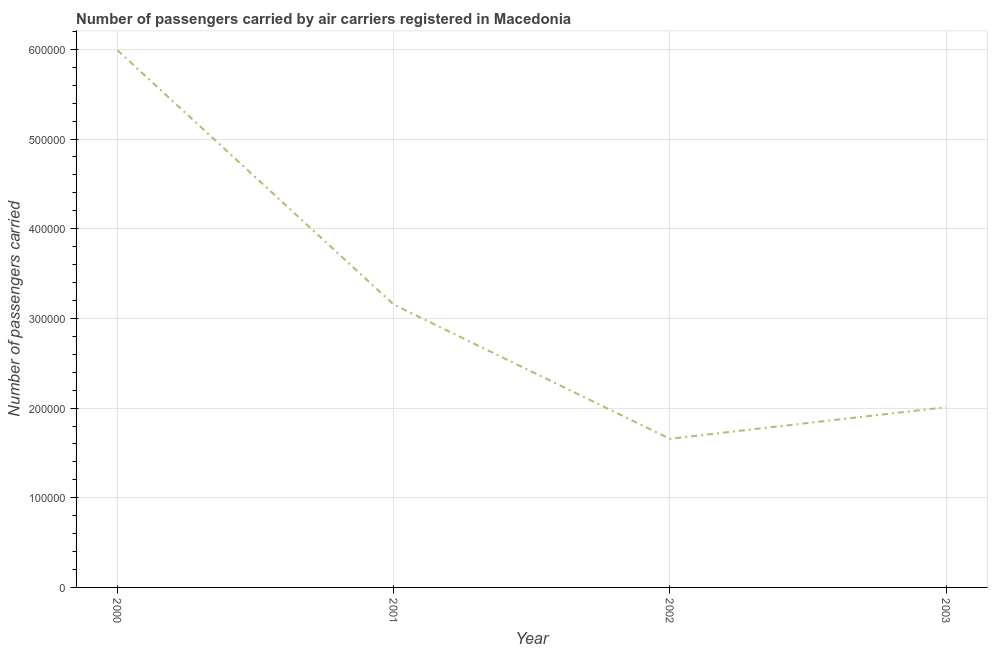What is the number of passengers carried in 2001?
Ensure brevity in your answer.  3.15e+05. Across all years, what is the maximum number of passengers carried?
Your response must be concise. 5.99e+05. Across all years, what is the minimum number of passengers carried?
Offer a terse response. 1.66e+05. In which year was the number of passengers carried minimum?
Your answer should be very brief. 2002. What is the sum of the number of passengers carried?
Make the answer very short. 1.28e+06. What is the difference between the number of passengers carried in 2000 and 2001?
Your answer should be very brief. 2.84e+05. What is the average number of passengers carried per year?
Offer a terse response. 3.20e+05. What is the median number of passengers carried?
Offer a very short reply. 2.58e+05. In how many years, is the number of passengers carried greater than 520000 ?
Provide a succinct answer. 1. Do a majority of the years between 2001 and 2003 (inclusive) have number of passengers carried greater than 300000 ?
Ensure brevity in your answer.  No. What is the ratio of the number of passengers carried in 2002 to that in 2003?
Ensure brevity in your answer.  0.82. What is the difference between the highest and the second highest number of passengers carried?
Your response must be concise. 2.84e+05. Is the sum of the number of passengers carried in 2002 and 2003 greater than the maximum number of passengers carried across all years?
Give a very brief answer. No. What is the difference between the highest and the lowest number of passengers carried?
Your answer should be very brief. 4.33e+05. How many years are there in the graph?
Your answer should be very brief. 4. What is the difference between two consecutive major ticks on the Y-axis?
Keep it short and to the point. 1.00e+05. Are the values on the major ticks of Y-axis written in scientific E-notation?
Keep it short and to the point. No. What is the title of the graph?
Keep it short and to the point. Number of passengers carried by air carriers registered in Macedonia. What is the label or title of the X-axis?
Provide a succinct answer. Year. What is the label or title of the Y-axis?
Provide a succinct answer. Number of passengers carried. What is the Number of passengers carried in 2000?
Keep it short and to the point. 5.99e+05. What is the Number of passengers carried in 2001?
Offer a very short reply. 3.15e+05. What is the Number of passengers carried in 2002?
Offer a terse response. 1.66e+05. What is the Number of passengers carried of 2003?
Your response must be concise. 2.01e+05. What is the difference between the Number of passengers carried in 2000 and 2001?
Give a very brief answer. 2.84e+05. What is the difference between the Number of passengers carried in 2000 and 2002?
Provide a succinct answer. 4.33e+05. What is the difference between the Number of passengers carried in 2000 and 2003?
Ensure brevity in your answer.  3.98e+05. What is the difference between the Number of passengers carried in 2001 and 2002?
Provide a succinct answer. 1.50e+05. What is the difference between the Number of passengers carried in 2001 and 2003?
Your answer should be very brief. 1.14e+05. What is the difference between the Number of passengers carried in 2002 and 2003?
Ensure brevity in your answer.  -3.52e+04. What is the ratio of the Number of passengers carried in 2000 to that in 2001?
Keep it short and to the point. 1.9. What is the ratio of the Number of passengers carried in 2000 to that in 2002?
Keep it short and to the point. 3.61. What is the ratio of the Number of passengers carried in 2000 to that in 2003?
Your answer should be very brief. 2.98. What is the ratio of the Number of passengers carried in 2001 to that in 2002?
Give a very brief answer. 1.9. What is the ratio of the Number of passengers carried in 2001 to that in 2003?
Your answer should be very brief. 1.57. What is the ratio of the Number of passengers carried in 2002 to that in 2003?
Provide a short and direct response. 0.82. 